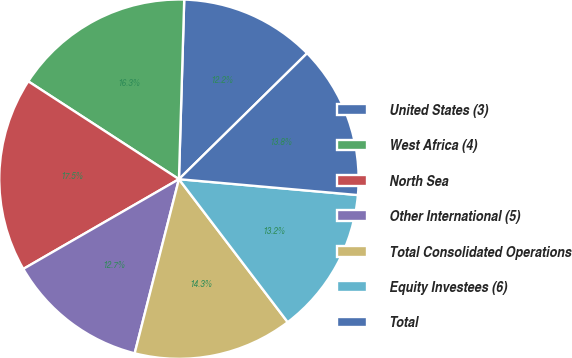Convert chart to OTSL. <chart><loc_0><loc_0><loc_500><loc_500><pie_chart><fcel>United States (3)<fcel>West Africa (4)<fcel>North Sea<fcel>Other International (5)<fcel>Total Consolidated Operations<fcel>Equity Investees (6)<fcel>Total<nl><fcel>12.17%<fcel>16.3%<fcel>17.49%<fcel>12.71%<fcel>14.31%<fcel>13.24%<fcel>13.77%<nl></chart> 